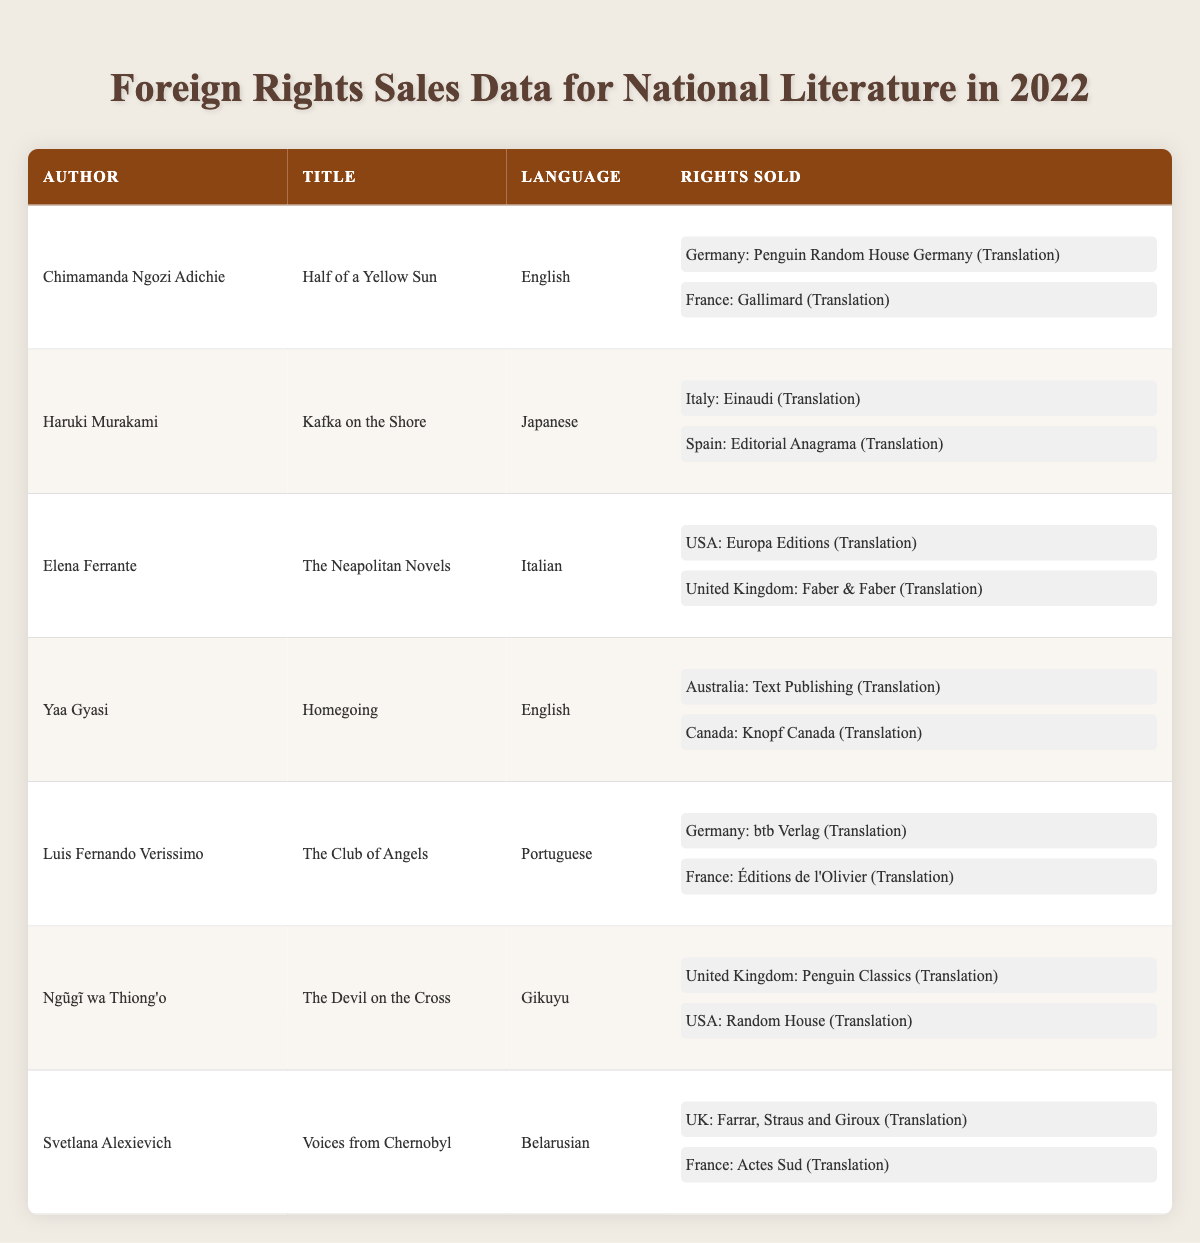What authors have sold their rights in France? The table lists the rights sold along with the corresponding countries. Scanning the data for 'France,' the authors associated with rights sold there are Chimamanda Ngozi Adichie, Luis Fernando Verissimo, and Svetlana Alexievich.
Answer: Chimamanda Ngozi Adichie, Luis Fernando Verissimo, Svetlana Alexievich How many different languages are represented in the table? Looking at the table, authors have works in English, Japanese, Italian, Portuguese, Gikuyu, and Belarusian. This adds up to a total of six distinct languages represented in the data.
Answer: 6 Which book had rights sold to both the USA and the UK? A quick review of the data points out that both Ngũgĩ wa Thiong'o's "The Devil on the Cross" has rights sold in the USA and the UK.
Answer: The Devil on the Cross Is there any author who has their rights sold to both Germany and France? By examining the data, it is clear that both Chimamanda Ngozi Adichie and Luis Fernando Verissimo have their rights sold to Germany and France, respectively. Thus the answer is yes.
Answer: Yes Which authors have sold their translation rights to Canada? Analyzing the rows related to rights sold, only Yaa Gyasi's "Homegoing" has sales listed for Canada in 2022.
Answer: Yaa Gyasi What is the total number of countries where rights have been sold for works written in English? The works by Chimamanda Ngozi Adichie and Yaa Gyasi are the two instances of English-language works, with their rights sold in Germany, France (Adichie), Australia, and Canada (Gyasi). The total number of unique countries is four.
Answer: 4 How many rights were sold in total for Japanese literature? Haruki Murakami's "Kafka on the Shore" shows that two rights were sold (to Italy and Spain).
Answer: 2 Is there a work in the table translated into Italian? The table shows that Elena Ferrante's "The Neapolitan Novels" has been translated, indicating that yes, there is a work translated into Italian.
Answer: Yes Which author had their rights sold to the most different countries? By looking closely at each author, Chimamanda Ngozi Adichie, Yaa Gyasi, and Luis Fernando Verissimo each have their rights sold in two different countries, which is the maximum in this specific table.
Answer: 2 What is the rights type for "Voices from Chernobyl"? For this title, the table states that the rights sold type is translation, as listed under the Rights Sold column.
Answer: Translation 